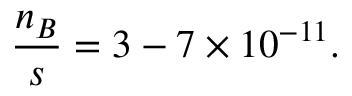<formula> <loc_0><loc_0><loc_500><loc_500>\frac { n _ { B } } { s } = 3 - 7 \times 1 0 ^ { - 1 1 } .</formula> 